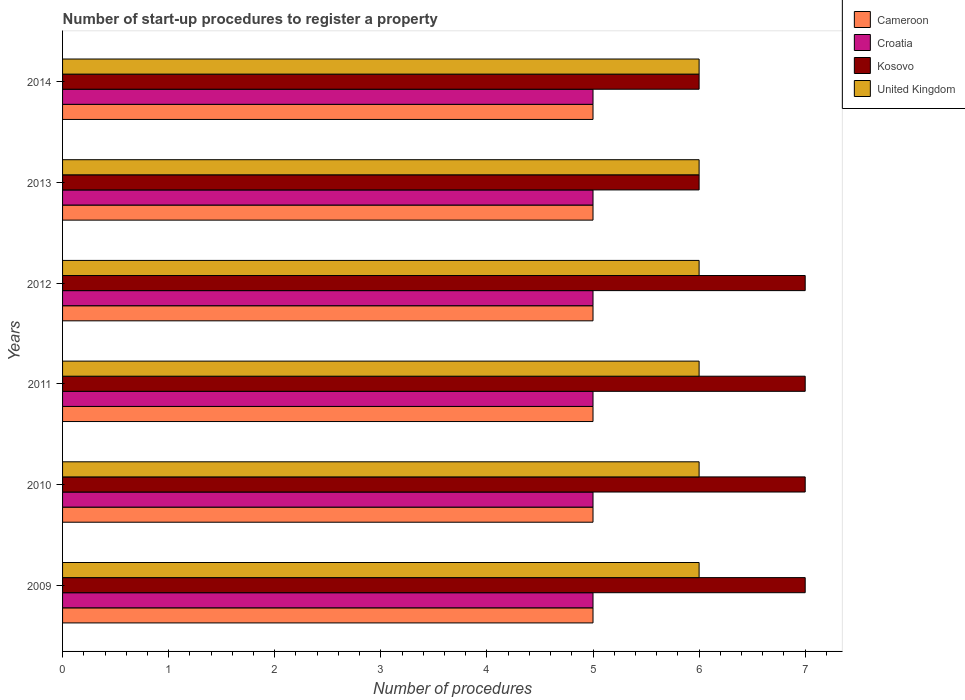How many different coloured bars are there?
Your answer should be compact. 4. Are the number of bars per tick equal to the number of legend labels?
Keep it short and to the point. Yes. Are the number of bars on each tick of the Y-axis equal?
Ensure brevity in your answer.  Yes. How many bars are there on the 6th tick from the top?
Offer a very short reply. 4. What is the label of the 5th group of bars from the top?
Make the answer very short. 2010. What is the number of procedures required to register a property in Kosovo in 2009?
Your answer should be very brief. 7. Across all years, what is the maximum number of procedures required to register a property in United Kingdom?
Give a very brief answer. 6. Across all years, what is the minimum number of procedures required to register a property in Cameroon?
Offer a very short reply. 5. What is the total number of procedures required to register a property in Cameroon in the graph?
Keep it short and to the point. 30. What is the difference between the number of procedures required to register a property in Cameroon in 2010 and that in 2013?
Provide a succinct answer. 0. What is the difference between the number of procedures required to register a property in Kosovo in 2009 and the number of procedures required to register a property in United Kingdom in 2012?
Give a very brief answer. 1. What is the average number of procedures required to register a property in Kosovo per year?
Your answer should be very brief. 6.67. In the year 2012, what is the difference between the number of procedures required to register a property in Croatia and number of procedures required to register a property in United Kingdom?
Provide a succinct answer. -1. Is the number of procedures required to register a property in Croatia in 2009 less than that in 2010?
Your response must be concise. No. What is the difference between the highest and the second highest number of procedures required to register a property in United Kingdom?
Provide a succinct answer. 0. Is the sum of the number of procedures required to register a property in Croatia in 2009 and 2014 greater than the maximum number of procedures required to register a property in United Kingdom across all years?
Your response must be concise. Yes. What does the 3rd bar from the top in 2014 represents?
Provide a short and direct response. Croatia. What does the 1st bar from the bottom in 2009 represents?
Your response must be concise. Cameroon. Is it the case that in every year, the sum of the number of procedures required to register a property in United Kingdom and number of procedures required to register a property in Cameroon is greater than the number of procedures required to register a property in Kosovo?
Keep it short and to the point. Yes. How many years are there in the graph?
Offer a terse response. 6. What is the difference between two consecutive major ticks on the X-axis?
Keep it short and to the point. 1. Are the values on the major ticks of X-axis written in scientific E-notation?
Keep it short and to the point. No. Does the graph contain grids?
Your response must be concise. No. How many legend labels are there?
Keep it short and to the point. 4. What is the title of the graph?
Give a very brief answer. Number of start-up procedures to register a property. What is the label or title of the X-axis?
Give a very brief answer. Number of procedures. What is the label or title of the Y-axis?
Provide a short and direct response. Years. What is the Number of procedures in Cameroon in 2009?
Ensure brevity in your answer.  5. What is the Number of procedures of Kosovo in 2009?
Provide a succinct answer. 7. What is the Number of procedures in United Kingdom in 2009?
Offer a very short reply. 6. What is the Number of procedures of Cameroon in 2010?
Give a very brief answer. 5. What is the Number of procedures of Kosovo in 2010?
Ensure brevity in your answer.  7. What is the Number of procedures in United Kingdom in 2010?
Your answer should be compact. 6. What is the Number of procedures in Cameroon in 2011?
Offer a very short reply. 5. What is the Number of procedures in Croatia in 2011?
Offer a very short reply. 5. What is the Number of procedures of United Kingdom in 2011?
Your answer should be compact. 6. What is the Number of procedures in Cameroon in 2012?
Make the answer very short. 5. What is the Number of procedures in Cameroon in 2013?
Your response must be concise. 5. What is the Number of procedures in Cameroon in 2014?
Provide a short and direct response. 5. What is the Number of procedures in United Kingdom in 2014?
Offer a terse response. 6. Across all years, what is the maximum Number of procedures of Cameroon?
Give a very brief answer. 5. Across all years, what is the maximum Number of procedures of United Kingdom?
Provide a succinct answer. 6. Across all years, what is the minimum Number of procedures in United Kingdom?
Your answer should be compact. 6. What is the total Number of procedures in Cameroon in the graph?
Offer a very short reply. 30. What is the total Number of procedures of Croatia in the graph?
Your response must be concise. 30. What is the difference between the Number of procedures in Cameroon in 2009 and that in 2010?
Your response must be concise. 0. What is the difference between the Number of procedures of United Kingdom in 2009 and that in 2010?
Keep it short and to the point. 0. What is the difference between the Number of procedures in Cameroon in 2009 and that in 2011?
Your answer should be compact. 0. What is the difference between the Number of procedures of Croatia in 2009 and that in 2011?
Keep it short and to the point. 0. What is the difference between the Number of procedures in Croatia in 2009 and that in 2012?
Keep it short and to the point. 0. What is the difference between the Number of procedures in Kosovo in 2009 and that in 2012?
Your answer should be compact. 0. What is the difference between the Number of procedures of Cameroon in 2009 and that in 2013?
Offer a very short reply. 0. What is the difference between the Number of procedures in Cameroon in 2009 and that in 2014?
Offer a terse response. 0. What is the difference between the Number of procedures in Croatia in 2009 and that in 2014?
Make the answer very short. 0. What is the difference between the Number of procedures in United Kingdom in 2009 and that in 2014?
Give a very brief answer. 0. What is the difference between the Number of procedures of Cameroon in 2010 and that in 2011?
Ensure brevity in your answer.  0. What is the difference between the Number of procedures in Kosovo in 2010 and that in 2011?
Offer a very short reply. 0. What is the difference between the Number of procedures in Cameroon in 2010 and that in 2012?
Your answer should be very brief. 0. What is the difference between the Number of procedures of Kosovo in 2010 and that in 2012?
Offer a terse response. 0. What is the difference between the Number of procedures in United Kingdom in 2010 and that in 2012?
Your answer should be compact. 0. What is the difference between the Number of procedures of United Kingdom in 2010 and that in 2013?
Your answer should be very brief. 0. What is the difference between the Number of procedures in Cameroon in 2010 and that in 2014?
Your answer should be very brief. 0. What is the difference between the Number of procedures in Kosovo in 2010 and that in 2014?
Your answer should be very brief. 1. What is the difference between the Number of procedures of United Kingdom in 2010 and that in 2014?
Keep it short and to the point. 0. What is the difference between the Number of procedures of Cameroon in 2011 and that in 2012?
Keep it short and to the point. 0. What is the difference between the Number of procedures in Croatia in 2011 and that in 2012?
Your response must be concise. 0. What is the difference between the Number of procedures of Kosovo in 2011 and that in 2012?
Your answer should be very brief. 0. What is the difference between the Number of procedures in Kosovo in 2011 and that in 2013?
Your answer should be compact. 1. What is the difference between the Number of procedures in Cameroon in 2011 and that in 2014?
Offer a terse response. 0. What is the difference between the Number of procedures in Croatia in 2011 and that in 2014?
Make the answer very short. 0. What is the difference between the Number of procedures of United Kingdom in 2011 and that in 2014?
Provide a short and direct response. 0. What is the difference between the Number of procedures of Cameroon in 2012 and that in 2014?
Your answer should be very brief. 0. What is the difference between the Number of procedures of Croatia in 2012 and that in 2014?
Offer a very short reply. 0. What is the difference between the Number of procedures in Kosovo in 2012 and that in 2014?
Ensure brevity in your answer.  1. What is the difference between the Number of procedures in United Kingdom in 2012 and that in 2014?
Give a very brief answer. 0. What is the difference between the Number of procedures in Cameroon in 2013 and that in 2014?
Provide a short and direct response. 0. What is the difference between the Number of procedures in Croatia in 2013 and that in 2014?
Provide a short and direct response. 0. What is the difference between the Number of procedures of Kosovo in 2013 and that in 2014?
Your response must be concise. 0. What is the difference between the Number of procedures of Cameroon in 2009 and the Number of procedures of Kosovo in 2010?
Your answer should be very brief. -2. What is the difference between the Number of procedures of Cameroon in 2009 and the Number of procedures of Croatia in 2011?
Give a very brief answer. 0. What is the difference between the Number of procedures of Croatia in 2009 and the Number of procedures of Kosovo in 2011?
Your answer should be very brief. -2. What is the difference between the Number of procedures in Croatia in 2009 and the Number of procedures in United Kingdom in 2011?
Your response must be concise. -1. What is the difference between the Number of procedures in Cameroon in 2009 and the Number of procedures in Kosovo in 2012?
Keep it short and to the point. -2. What is the difference between the Number of procedures of Cameroon in 2009 and the Number of procedures of United Kingdom in 2012?
Ensure brevity in your answer.  -1. What is the difference between the Number of procedures of Croatia in 2009 and the Number of procedures of United Kingdom in 2012?
Give a very brief answer. -1. What is the difference between the Number of procedures of Kosovo in 2009 and the Number of procedures of United Kingdom in 2012?
Offer a very short reply. 1. What is the difference between the Number of procedures in Cameroon in 2009 and the Number of procedures in Croatia in 2013?
Your answer should be very brief. 0. What is the difference between the Number of procedures of Cameroon in 2009 and the Number of procedures of Kosovo in 2013?
Offer a terse response. -1. What is the difference between the Number of procedures in Cameroon in 2009 and the Number of procedures in United Kingdom in 2013?
Make the answer very short. -1. What is the difference between the Number of procedures of Croatia in 2009 and the Number of procedures of Kosovo in 2013?
Your response must be concise. -1. What is the difference between the Number of procedures of Croatia in 2009 and the Number of procedures of United Kingdom in 2013?
Offer a very short reply. -1. What is the difference between the Number of procedures in Cameroon in 2009 and the Number of procedures in Kosovo in 2014?
Provide a succinct answer. -1. What is the difference between the Number of procedures of Cameroon in 2009 and the Number of procedures of United Kingdom in 2014?
Give a very brief answer. -1. What is the difference between the Number of procedures in Kosovo in 2009 and the Number of procedures in United Kingdom in 2014?
Ensure brevity in your answer.  1. What is the difference between the Number of procedures of Cameroon in 2010 and the Number of procedures of United Kingdom in 2011?
Give a very brief answer. -1. What is the difference between the Number of procedures of Cameroon in 2010 and the Number of procedures of United Kingdom in 2012?
Offer a very short reply. -1. What is the difference between the Number of procedures of Croatia in 2010 and the Number of procedures of United Kingdom in 2012?
Ensure brevity in your answer.  -1. What is the difference between the Number of procedures of Kosovo in 2010 and the Number of procedures of United Kingdom in 2012?
Keep it short and to the point. 1. What is the difference between the Number of procedures of Cameroon in 2010 and the Number of procedures of United Kingdom in 2013?
Give a very brief answer. -1. What is the difference between the Number of procedures of Croatia in 2010 and the Number of procedures of Kosovo in 2013?
Provide a succinct answer. -1. What is the difference between the Number of procedures of Kosovo in 2010 and the Number of procedures of United Kingdom in 2013?
Your response must be concise. 1. What is the difference between the Number of procedures in Cameroon in 2010 and the Number of procedures in Croatia in 2014?
Your answer should be very brief. 0. What is the difference between the Number of procedures in Croatia in 2010 and the Number of procedures in Kosovo in 2014?
Keep it short and to the point. -1. What is the difference between the Number of procedures of Croatia in 2010 and the Number of procedures of United Kingdom in 2014?
Ensure brevity in your answer.  -1. What is the difference between the Number of procedures of Cameroon in 2011 and the Number of procedures of Croatia in 2012?
Provide a succinct answer. 0. What is the difference between the Number of procedures in Cameroon in 2011 and the Number of procedures in Kosovo in 2012?
Ensure brevity in your answer.  -2. What is the difference between the Number of procedures in Cameroon in 2011 and the Number of procedures in United Kingdom in 2012?
Keep it short and to the point. -1. What is the difference between the Number of procedures of Kosovo in 2011 and the Number of procedures of United Kingdom in 2012?
Offer a very short reply. 1. What is the difference between the Number of procedures of Cameroon in 2011 and the Number of procedures of Kosovo in 2013?
Offer a very short reply. -1. What is the difference between the Number of procedures in Kosovo in 2011 and the Number of procedures in United Kingdom in 2013?
Your answer should be very brief. 1. What is the difference between the Number of procedures in Cameroon in 2011 and the Number of procedures in Croatia in 2014?
Offer a terse response. 0. What is the difference between the Number of procedures of Cameroon in 2011 and the Number of procedures of Kosovo in 2014?
Keep it short and to the point. -1. What is the difference between the Number of procedures in Croatia in 2011 and the Number of procedures in United Kingdom in 2014?
Offer a very short reply. -1. What is the difference between the Number of procedures in Cameroon in 2012 and the Number of procedures in Croatia in 2013?
Your response must be concise. 0. What is the difference between the Number of procedures in Cameroon in 2012 and the Number of procedures in Kosovo in 2013?
Provide a succinct answer. -1. What is the difference between the Number of procedures in Cameroon in 2012 and the Number of procedures in Croatia in 2014?
Make the answer very short. 0. What is the difference between the Number of procedures of Cameroon in 2012 and the Number of procedures of United Kingdom in 2014?
Provide a succinct answer. -1. What is the difference between the Number of procedures of Croatia in 2012 and the Number of procedures of United Kingdom in 2014?
Keep it short and to the point. -1. What is the difference between the Number of procedures of Cameroon in 2013 and the Number of procedures of Kosovo in 2014?
Give a very brief answer. -1. What is the difference between the Number of procedures of Kosovo in 2013 and the Number of procedures of United Kingdom in 2014?
Give a very brief answer. 0. What is the average Number of procedures of Kosovo per year?
Offer a terse response. 6.67. What is the average Number of procedures in United Kingdom per year?
Keep it short and to the point. 6. In the year 2009, what is the difference between the Number of procedures in Cameroon and Number of procedures in Croatia?
Your answer should be compact. 0. In the year 2009, what is the difference between the Number of procedures of Cameroon and Number of procedures of United Kingdom?
Your answer should be very brief. -1. In the year 2010, what is the difference between the Number of procedures of Cameroon and Number of procedures of Croatia?
Offer a terse response. 0. In the year 2010, what is the difference between the Number of procedures of Croatia and Number of procedures of United Kingdom?
Ensure brevity in your answer.  -1. In the year 2011, what is the difference between the Number of procedures in Cameroon and Number of procedures in Croatia?
Your response must be concise. 0. In the year 2011, what is the difference between the Number of procedures in Cameroon and Number of procedures in Kosovo?
Give a very brief answer. -2. In the year 2011, what is the difference between the Number of procedures in Cameroon and Number of procedures in United Kingdom?
Offer a very short reply. -1. In the year 2011, what is the difference between the Number of procedures in Croatia and Number of procedures in United Kingdom?
Provide a succinct answer. -1. In the year 2012, what is the difference between the Number of procedures of Cameroon and Number of procedures of Croatia?
Provide a short and direct response. 0. In the year 2012, what is the difference between the Number of procedures of Cameroon and Number of procedures of United Kingdom?
Keep it short and to the point. -1. In the year 2012, what is the difference between the Number of procedures in Croatia and Number of procedures in Kosovo?
Your answer should be very brief. -2. In the year 2013, what is the difference between the Number of procedures in Cameroon and Number of procedures in Croatia?
Your answer should be compact. 0. In the year 2013, what is the difference between the Number of procedures of Croatia and Number of procedures of Kosovo?
Make the answer very short. -1. In the year 2014, what is the difference between the Number of procedures of Cameroon and Number of procedures of Croatia?
Your response must be concise. 0. In the year 2014, what is the difference between the Number of procedures of Cameroon and Number of procedures of United Kingdom?
Ensure brevity in your answer.  -1. In the year 2014, what is the difference between the Number of procedures in Croatia and Number of procedures in United Kingdom?
Make the answer very short. -1. In the year 2014, what is the difference between the Number of procedures of Kosovo and Number of procedures of United Kingdom?
Provide a short and direct response. 0. What is the ratio of the Number of procedures of Cameroon in 2009 to that in 2010?
Your response must be concise. 1. What is the ratio of the Number of procedures in Croatia in 2009 to that in 2010?
Your response must be concise. 1. What is the ratio of the Number of procedures in United Kingdom in 2009 to that in 2010?
Your answer should be compact. 1. What is the ratio of the Number of procedures of Cameroon in 2009 to that in 2011?
Your answer should be very brief. 1. What is the ratio of the Number of procedures in Croatia in 2009 to that in 2011?
Your answer should be very brief. 1. What is the ratio of the Number of procedures of Cameroon in 2009 to that in 2012?
Your answer should be compact. 1. What is the ratio of the Number of procedures of Kosovo in 2009 to that in 2012?
Provide a short and direct response. 1. What is the ratio of the Number of procedures in United Kingdom in 2009 to that in 2012?
Ensure brevity in your answer.  1. What is the ratio of the Number of procedures in Croatia in 2009 to that in 2013?
Your answer should be very brief. 1. What is the ratio of the Number of procedures of Cameroon in 2009 to that in 2014?
Ensure brevity in your answer.  1. What is the ratio of the Number of procedures in Kosovo in 2009 to that in 2014?
Make the answer very short. 1.17. What is the ratio of the Number of procedures of Cameroon in 2010 to that in 2011?
Make the answer very short. 1. What is the ratio of the Number of procedures in United Kingdom in 2010 to that in 2011?
Provide a succinct answer. 1. What is the ratio of the Number of procedures in Kosovo in 2010 to that in 2012?
Your answer should be very brief. 1. What is the ratio of the Number of procedures in United Kingdom in 2010 to that in 2013?
Offer a very short reply. 1. What is the ratio of the Number of procedures in Cameroon in 2010 to that in 2014?
Provide a short and direct response. 1. What is the ratio of the Number of procedures of United Kingdom in 2011 to that in 2012?
Offer a terse response. 1. What is the ratio of the Number of procedures in Cameroon in 2011 to that in 2013?
Make the answer very short. 1. What is the ratio of the Number of procedures of Croatia in 2011 to that in 2013?
Provide a succinct answer. 1. What is the ratio of the Number of procedures in Kosovo in 2011 to that in 2013?
Offer a terse response. 1.17. What is the ratio of the Number of procedures in United Kingdom in 2011 to that in 2013?
Provide a short and direct response. 1. What is the ratio of the Number of procedures of Cameroon in 2011 to that in 2014?
Keep it short and to the point. 1. What is the ratio of the Number of procedures of Croatia in 2011 to that in 2014?
Keep it short and to the point. 1. What is the ratio of the Number of procedures of Kosovo in 2011 to that in 2014?
Keep it short and to the point. 1.17. What is the ratio of the Number of procedures in Cameroon in 2012 to that in 2013?
Give a very brief answer. 1. What is the ratio of the Number of procedures of Croatia in 2012 to that in 2013?
Your answer should be very brief. 1. What is the ratio of the Number of procedures in Kosovo in 2012 to that in 2013?
Keep it short and to the point. 1.17. What is the ratio of the Number of procedures of Cameroon in 2012 to that in 2014?
Make the answer very short. 1. What is the ratio of the Number of procedures of Croatia in 2012 to that in 2014?
Ensure brevity in your answer.  1. What is the ratio of the Number of procedures in United Kingdom in 2012 to that in 2014?
Give a very brief answer. 1. What is the ratio of the Number of procedures of Croatia in 2013 to that in 2014?
Offer a terse response. 1. What is the ratio of the Number of procedures in Kosovo in 2013 to that in 2014?
Keep it short and to the point. 1. What is the ratio of the Number of procedures in United Kingdom in 2013 to that in 2014?
Keep it short and to the point. 1. What is the difference between the highest and the second highest Number of procedures of Kosovo?
Offer a terse response. 0. What is the difference between the highest and the lowest Number of procedures in Kosovo?
Your answer should be compact. 1. 